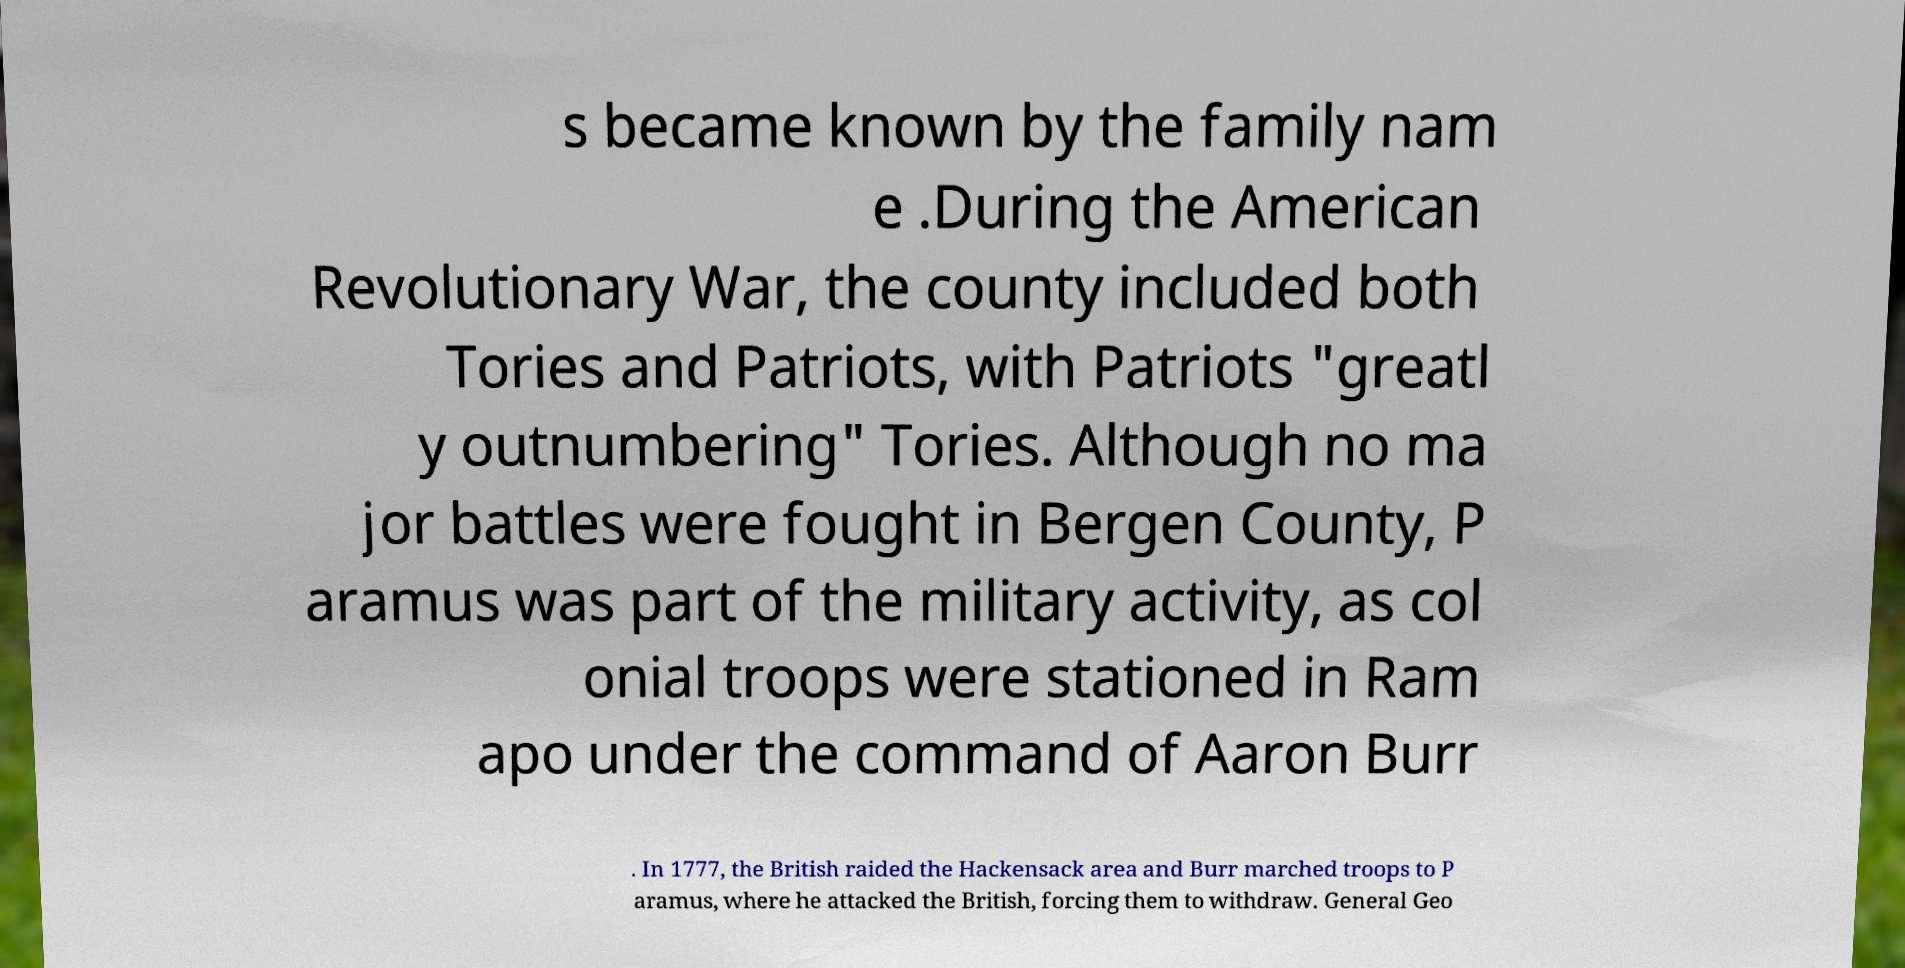Could you extract and type out the text from this image? s became known by the family nam e .During the American Revolutionary War, the county included both Tories and Patriots, with Patriots "greatl y outnumbering" Tories. Although no ma jor battles were fought in Bergen County, P aramus was part of the military activity, as col onial troops were stationed in Ram apo under the command of Aaron Burr . In 1777, the British raided the Hackensack area and Burr marched troops to P aramus, where he attacked the British, forcing them to withdraw. General Geo 